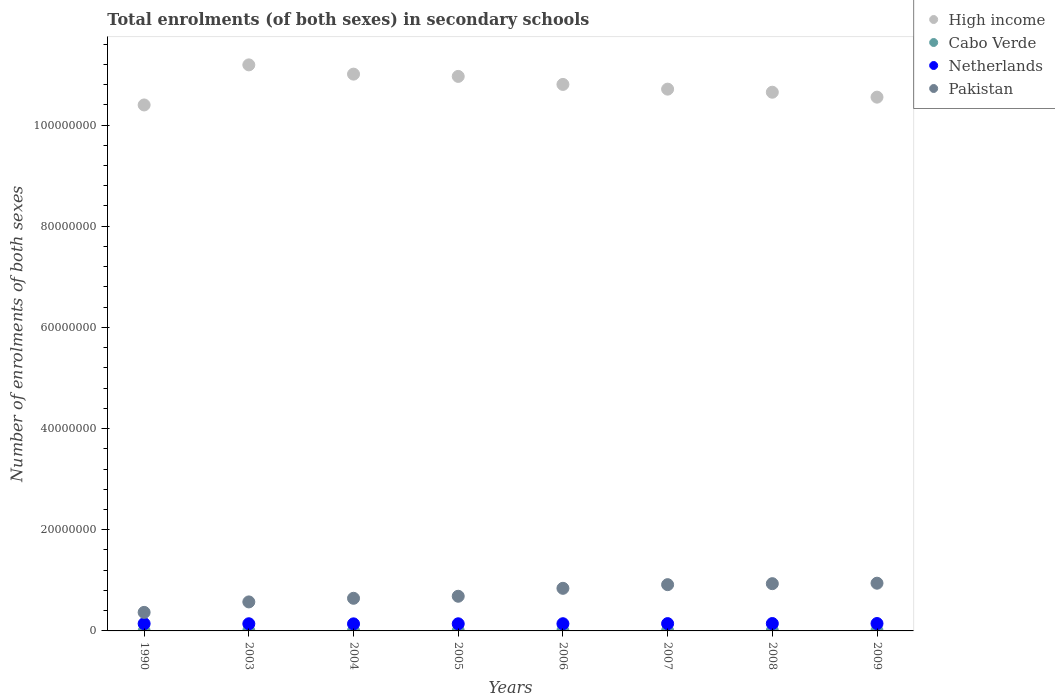What is the number of enrolments in secondary schools in Netherlands in 2003?
Offer a terse response. 1.42e+06. Across all years, what is the maximum number of enrolments in secondary schools in Pakistan?
Make the answer very short. 9.43e+06. Across all years, what is the minimum number of enrolments in secondary schools in Netherlands?
Your response must be concise. 1.40e+06. In which year was the number of enrolments in secondary schools in Pakistan maximum?
Ensure brevity in your answer.  2009. What is the total number of enrolments in secondary schools in Cabo Verde in the graph?
Offer a terse response. 4.05e+05. What is the difference between the number of enrolments in secondary schools in Cabo Verde in 1990 and that in 2005?
Give a very brief answer. -4.48e+04. What is the difference between the number of enrolments in secondary schools in Pakistan in 2006 and the number of enrolments in secondary schools in Cabo Verde in 1990?
Your response must be concise. 8.41e+06. What is the average number of enrolments in secondary schools in High income per year?
Give a very brief answer. 1.08e+08. In the year 2009, what is the difference between the number of enrolments in secondary schools in Pakistan and number of enrolments in secondary schools in High income?
Offer a terse response. -9.61e+07. In how many years, is the number of enrolments in secondary schools in Cabo Verde greater than 108000000?
Your response must be concise. 0. What is the ratio of the number of enrolments in secondary schools in High income in 2006 to that in 2007?
Provide a succinct answer. 1.01. What is the difference between the highest and the second highest number of enrolments in secondary schools in Netherlands?
Your response must be concise. 1958. What is the difference between the highest and the lowest number of enrolments in secondary schools in Pakistan?
Your response must be concise. 5.77e+06. In how many years, is the number of enrolments in secondary schools in Cabo Verde greater than the average number of enrolments in secondary schools in Cabo Verde taken over all years?
Make the answer very short. 5. Is the sum of the number of enrolments in secondary schools in High income in 1990 and 2009 greater than the maximum number of enrolments in secondary schools in Netherlands across all years?
Provide a short and direct response. Yes. Does the number of enrolments in secondary schools in Pakistan monotonically increase over the years?
Give a very brief answer. Yes. Is the number of enrolments in secondary schools in High income strictly greater than the number of enrolments in secondary schools in Pakistan over the years?
Your response must be concise. Yes. Is the number of enrolments in secondary schools in Netherlands strictly less than the number of enrolments in secondary schools in Pakistan over the years?
Give a very brief answer. Yes. How many dotlines are there?
Provide a succinct answer. 4. How many years are there in the graph?
Offer a terse response. 8. What is the difference between two consecutive major ticks on the Y-axis?
Keep it short and to the point. 2.00e+07. Are the values on the major ticks of Y-axis written in scientific E-notation?
Make the answer very short. No. Does the graph contain grids?
Your answer should be compact. No. Where does the legend appear in the graph?
Keep it short and to the point. Top right. How are the legend labels stacked?
Keep it short and to the point. Vertical. What is the title of the graph?
Provide a succinct answer. Total enrolments (of both sexes) in secondary schools. Does "Japan" appear as one of the legend labels in the graph?
Keep it short and to the point. No. What is the label or title of the X-axis?
Provide a short and direct response. Years. What is the label or title of the Y-axis?
Keep it short and to the point. Number of enrolments of both sexes. What is the Number of enrolments of both sexes of High income in 1990?
Your answer should be very brief. 1.04e+08. What is the Number of enrolments of both sexes in Cabo Verde in 1990?
Provide a short and direct response. 7866. What is the Number of enrolments of both sexes of Netherlands in 1990?
Make the answer very short. 1.44e+06. What is the Number of enrolments of both sexes in Pakistan in 1990?
Provide a short and direct response. 3.67e+06. What is the Number of enrolments of both sexes of High income in 2003?
Offer a terse response. 1.12e+08. What is the Number of enrolments of both sexes of Cabo Verde in 2003?
Give a very brief answer. 4.95e+04. What is the Number of enrolments of both sexes in Netherlands in 2003?
Your response must be concise. 1.42e+06. What is the Number of enrolments of both sexes of Pakistan in 2003?
Keep it short and to the point. 5.73e+06. What is the Number of enrolments of both sexes of High income in 2004?
Your answer should be compact. 1.10e+08. What is the Number of enrolments of both sexes of Cabo Verde in 2004?
Keep it short and to the point. 4.98e+04. What is the Number of enrolments of both sexes of Netherlands in 2004?
Your response must be concise. 1.40e+06. What is the Number of enrolments of both sexes in Pakistan in 2004?
Keep it short and to the point. 6.45e+06. What is the Number of enrolments of both sexes in High income in 2005?
Make the answer very short. 1.10e+08. What is the Number of enrolments of both sexes of Cabo Verde in 2005?
Your answer should be very brief. 5.27e+04. What is the Number of enrolments of both sexes of Netherlands in 2005?
Offer a terse response. 1.41e+06. What is the Number of enrolments of both sexes of Pakistan in 2005?
Offer a very short reply. 6.85e+06. What is the Number of enrolments of both sexes of High income in 2006?
Your response must be concise. 1.08e+08. What is the Number of enrolments of both sexes in Cabo Verde in 2006?
Your answer should be compact. 6.15e+04. What is the Number of enrolments of both sexes in Netherlands in 2006?
Your answer should be very brief. 1.42e+06. What is the Number of enrolments of both sexes in Pakistan in 2006?
Offer a terse response. 8.42e+06. What is the Number of enrolments of both sexes of High income in 2007?
Give a very brief answer. 1.07e+08. What is the Number of enrolments of both sexes of Cabo Verde in 2007?
Provide a succinct answer. 6.08e+04. What is the Number of enrolments of both sexes of Netherlands in 2007?
Keep it short and to the point. 1.44e+06. What is the Number of enrolments of both sexes of Pakistan in 2007?
Your answer should be compact. 9.15e+06. What is the Number of enrolments of both sexes of High income in 2008?
Your answer should be compact. 1.06e+08. What is the Number of enrolments of both sexes of Cabo Verde in 2008?
Ensure brevity in your answer.  6.19e+04. What is the Number of enrolments of both sexes in Netherlands in 2008?
Your response must be concise. 1.46e+06. What is the Number of enrolments of both sexes in Pakistan in 2008?
Provide a short and direct response. 9.34e+06. What is the Number of enrolments of both sexes of High income in 2009?
Keep it short and to the point. 1.06e+08. What is the Number of enrolments of both sexes in Cabo Verde in 2009?
Offer a very short reply. 6.08e+04. What is the Number of enrolments of both sexes in Netherlands in 2009?
Your response must be concise. 1.46e+06. What is the Number of enrolments of both sexes in Pakistan in 2009?
Make the answer very short. 9.43e+06. Across all years, what is the maximum Number of enrolments of both sexes in High income?
Your answer should be compact. 1.12e+08. Across all years, what is the maximum Number of enrolments of both sexes of Cabo Verde?
Ensure brevity in your answer.  6.19e+04. Across all years, what is the maximum Number of enrolments of both sexes in Netherlands?
Provide a short and direct response. 1.46e+06. Across all years, what is the maximum Number of enrolments of both sexes in Pakistan?
Keep it short and to the point. 9.43e+06. Across all years, what is the minimum Number of enrolments of both sexes in High income?
Make the answer very short. 1.04e+08. Across all years, what is the minimum Number of enrolments of both sexes of Cabo Verde?
Give a very brief answer. 7866. Across all years, what is the minimum Number of enrolments of both sexes of Netherlands?
Your answer should be very brief. 1.40e+06. Across all years, what is the minimum Number of enrolments of both sexes in Pakistan?
Provide a succinct answer. 3.67e+06. What is the total Number of enrolments of both sexes in High income in the graph?
Provide a short and direct response. 8.63e+08. What is the total Number of enrolments of both sexes of Cabo Verde in the graph?
Offer a terse response. 4.05e+05. What is the total Number of enrolments of both sexes of Netherlands in the graph?
Provide a short and direct response. 1.14e+07. What is the total Number of enrolments of both sexes of Pakistan in the graph?
Keep it short and to the point. 5.90e+07. What is the difference between the Number of enrolments of both sexes in High income in 1990 and that in 2003?
Your response must be concise. -7.92e+06. What is the difference between the Number of enrolments of both sexes of Cabo Verde in 1990 and that in 2003?
Provide a succinct answer. -4.17e+04. What is the difference between the Number of enrolments of both sexes in Netherlands in 1990 and that in 2003?
Provide a succinct answer. 2.14e+04. What is the difference between the Number of enrolments of both sexes of Pakistan in 1990 and that in 2003?
Offer a terse response. -2.07e+06. What is the difference between the Number of enrolments of both sexes of High income in 1990 and that in 2004?
Provide a short and direct response. -6.09e+06. What is the difference between the Number of enrolments of both sexes in Cabo Verde in 1990 and that in 2004?
Provide a succinct answer. -4.19e+04. What is the difference between the Number of enrolments of both sexes of Netherlands in 1990 and that in 2004?
Your answer should be compact. 3.99e+04. What is the difference between the Number of enrolments of both sexes in Pakistan in 1990 and that in 2004?
Make the answer very short. -2.78e+06. What is the difference between the Number of enrolments of both sexes in High income in 1990 and that in 2005?
Offer a terse response. -5.64e+06. What is the difference between the Number of enrolments of both sexes in Cabo Verde in 1990 and that in 2005?
Make the answer very short. -4.48e+04. What is the difference between the Number of enrolments of both sexes of Netherlands in 1990 and that in 2005?
Make the answer very short. 2.61e+04. What is the difference between the Number of enrolments of both sexes in Pakistan in 1990 and that in 2005?
Provide a succinct answer. -3.19e+06. What is the difference between the Number of enrolments of both sexes of High income in 1990 and that in 2006?
Make the answer very short. -4.06e+06. What is the difference between the Number of enrolments of both sexes of Cabo Verde in 1990 and that in 2006?
Your answer should be very brief. -5.36e+04. What is the difference between the Number of enrolments of both sexes of Netherlands in 1990 and that in 2006?
Make the answer very short. 1.33e+04. What is the difference between the Number of enrolments of both sexes in Pakistan in 1990 and that in 2006?
Offer a terse response. -4.76e+06. What is the difference between the Number of enrolments of both sexes in High income in 1990 and that in 2007?
Offer a very short reply. -3.13e+06. What is the difference between the Number of enrolments of both sexes of Cabo Verde in 1990 and that in 2007?
Give a very brief answer. -5.29e+04. What is the difference between the Number of enrolments of both sexes in Netherlands in 1990 and that in 2007?
Your answer should be compact. -7456. What is the difference between the Number of enrolments of both sexes of Pakistan in 1990 and that in 2007?
Offer a terse response. -5.48e+06. What is the difference between the Number of enrolments of both sexes of High income in 1990 and that in 2008?
Your answer should be very brief. -2.51e+06. What is the difference between the Number of enrolments of both sexes in Cabo Verde in 1990 and that in 2008?
Your response must be concise. -5.40e+04. What is the difference between the Number of enrolments of both sexes in Netherlands in 1990 and that in 2008?
Your answer should be compact. -2.39e+04. What is the difference between the Number of enrolments of both sexes of Pakistan in 1990 and that in 2008?
Give a very brief answer. -5.67e+06. What is the difference between the Number of enrolments of both sexes in High income in 1990 and that in 2009?
Provide a succinct answer. -1.54e+06. What is the difference between the Number of enrolments of both sexes in Cabo Verde in 1990 and that in 2009?
Your answer should be very brief. -5.29e+04. What is the difference between the Number of enrolments of both sexes of Netherlands in 1990 and that in 2009?
Offer a terse response. -2.59e+04. What is the difference between the Number of enrolments of both sexes in Pakistan in 1990 and that in 2009?
Provide a short and direct response. -5.77e+06. What is the difference between the Number of enrolments of both sexes of High income in 2003 and that in 2004?
Your answer should be compact. 1.83e+06. What is the difference between the Number of enrolments of both sexes in Cabo Verde in 2003 and that in 2004?
Provide a succinct answer. -268. What is the difference between the Number of enrolments of both sexes of Netherlands in 2003 and that in 2004?
Keep it short and to the point. 1.85e+04. What is the difference between the Number of enrolments of both sexes in Pakistan in 2003 and that in 2004?
Your answer should be compact. -7.15e+05. What is the difference between the Number of enrolments of both sexes in High income in 2003 and that in 2005?
Provide a succinct answer. 2.28e+06. What is the difference between the Number of enrolments of both sexes in Cabo Verde in 2003 and that in 2005?
Keep it short and to the point. -3149. What is the difference between the Number of enrolments of both sexes in Netherlands in 2003 and that in 2005?
Provide a succinct answer. 4623. What is the difference between the Number of enrolments of both sexes in Pakistan in 2003 and that in 2005?
Make the answer very short. -1.12e+06. What is the difference between the Number of enrolments of both sexes of High income in 2003 and that in 2006?
Ensure brevity in your answer.  3.86e+06. What is the difference between the Number of enrolments of both sexes of Cabo Verde in 2003 and that in 2006?
Your answer should be very brief. -1.19e+04. What is the difference between the Number of enrolments of both sexes of Netherlands in 2003 and that in 2006?
Provide a short and direct response. -8092. What is the difference between the Number of enrolments of both sexes in Pakistan in 2003 and that in 2006?
Provide a short and direct response. -2.69e+06. What is the difference between the Number of enrolments of both sexes in High income in 2003 and that in 2007?
Offer a very short reply. 4.80e+06. What is the difference between the Number of enrolments of both sexes in Cabo Verde in 2003 and that in 2007?
Give a very brief answer. -1.13e+04. What is the difference between the Number of enrolments of both sexes of Netherlands in 2003 and that in 2007?
Provide a succinct answer. -2.89e+04. What is the difference between the Number of enrolments of both sexes in Pakistan in 2003 and that in 2007?
Provide a succinct answer. -3.41e+06. What is the difference between the Number of enrolments of both sexes in High income in 2003 and that in 2008?
Your answer should be compact. 5.41e+06. What is the difference between the Number of enrolments of both sexes of Cabo Verde in 2003 and that in 2008?
Provide a short and direct response. -1.24e+04. What is the difference between the Number of enrolments of both sexes in Netherlands in 2003 and that in 2008?
Your answer should be compact. -4.53e+04. What is the difference between the Number of enrolments of both sexes of Pakistan in 2003 and that in 2008?
Ensure brevity in your answer.  -3.61e+06. What is the difference between the Number of enrolments of both sexes of High income in 2003 and that in 2009?
Provide a short and direct response. 6.38e+06. What is the difference between the Number of enrolments of both sexes of Cabo Verde in 2003 and that in 2009?
Your answer should be very brief. -1.12e+04. What is the difference between the Number of enrolments of both sexes of Netherlands in 2003 and that in 2009?
Offer a very short reply. -4.73e+04. What is the difference between the Number of enrolments of both sexes in Pakistan in 2003 and that in 2009?
Offer a terse response. -3.70e+06. What is the difference between the Number of enrolments of both sexes of High income in 2004 and that in 2005?
Ensure brevity in your answer.  4.50e+05. What is the difference between the Number of enrolments of both sexes of Cabo Verde in 2004 and that in 2005?
Ensure brevity in your answer.  -2881. What is the difference between the Number of enrolments of both sexes in Netherlands in 2004 and that in 2005?
Provide a short and direct response. -1.39e+04. What is the difference between the Number of enrolments of both sexes of Pakistan in 2004 and that in 2005?
Ensure brevity in your answer.  -4.03e+05. What is the difference between the Number of enrolments of both sexes in High income in 2004 and that in 2006?
Keep it short and to the point. 2.03e+06. What is the difference between the Number of enrolments of both sexes in Cabo Verde in 2004 and that in 2006?
Give a very brief answer. -1.17e+04. What is the difference between the Number of enrolments of both sexes of Netherlands in 2004 and that in 2006?
Your answer should be very brief. -2.66e+04. What is the difference between the Number of enrolments of both sexes in Pakistan in 2004 and that in 2006?
Make the answer very short. -1.97e+06. What is the difference between the Number of enrolments of both sexes in High income in 2004 and that in 2007?
Your answer should be compact. 2.97e+06. What is the difference between the Number of enrolments of both sexes of Cabo Verde in 2004 and that in 2007?
Your answer should be very brief. -1.10e+04. What is the difference between the Number of enrolments of both sexes of Netherlands in 2004 and that in 2007?
Make the answer very short. -4.74e+04. What is the difference between the Number of enrolments of both sexes in Pakistan in 2004 and that in 2007?
Your response must be concise. -2.70e+06. What is the difference between the Number of enrolments of both sexes of High income in 2004 and that in 2008?
Give a very brief answer. 3.58e+06. What is the difference between the Number of enrolments of both sexes of Cabo Verde in 2004 and that in 2008?
Provide a short and direct response. -1.21e+04. What is the difference between the Number of enrolments of both sexes of Netherlands in 2004 and that in 2008?
Your response must be concise. -6.38e+04. What is the difference between the Number of enrolments of both sexes of Pakistan in 2004 and that in 2008?
Offer a very short reply. -2.89e+06. What is the difference between the Number of enrolments of both sexes of High income in 2004 and that in 2009?
Provide a succinct answer. 4.55e+06. What is the difference between the Number of enrolments of both sexes of Cabo Verde in 2004 and that in 2009?
Your response must be concise. -1.10e+04. What is the difference between the Number of enrolments of both sexes of Netherlands in 2004 and that in 2009?
Offer a very short reply. -6.58e+04. What is the difference between the Number of enrolments of both sexes of Pakistan in 2004 and that in 2009?
Give a very brief answer. -2.98e+06. What is the difference between the Number of enrolments of both sexes in High income in 2005 and that in 2006?
Offer a very short reply. 1.58e+06. What is the difference between the Number of enrolments of both sexes of Cabo Verde in 2005 and that in 2006?
Keep it short and to the point. -8794. What is the difference between the Number of enrolments of both sexes in Netherlands in 2005 and that in 2006?
Provide a succinct answer. -1.27e+04. What is the difference between the Number of enrolments of both sexes of Pakistan in 2005 and that in 2006?
Offer a very short reply. -1.57e+06. What is the difference between the Number of enrolments of both sexes in High income in 2005 and that in 2007?
Give a very brief answer. 2.52e+06. What is the difference between the Number of enrolments of both sexes of Cabo Verde in 2005 and that in 2007?
Make the answer very short. -8112. What is the difference between the Number of enrolments of both sexes in Netherlands in 2005 and that in 2007?
Ensure brevity in your answer.  -3.35e+04. What is the difference between the Number of enrolments of both sexes of Pakistan in 2005 and that in 2007?
Your answer should be compact. -2.29e+06. What is the difference between the Number of enrolments of both sexes of High income in 2005 and that in 2008?
Your answer should be very brief. 3.13e+06. What is the difference between the Number of enrolments of both sexes of Cabo Verde in 2005 and that in 2008?
Your response must be concise. -9235. What is the difference between the Number of enrolments of both sexes in Netherlands in 2005 and that in 2008?
Make the answer very short. -5.00e+04. What is the difference between the Number of enrolments of both sexes in Pakistan in 2005 and that in 2008?
Your answer should be very brief. -2.49e+06. What is the difference between the Number of enrolments of both sexes of High income in 2005 and that in 2009?
Offer a terse response. 4.10e+06. What is the difference between the Number of enrolments of both sexes of Cabo Verde in 2005 and that in 2009?
Give a very brief answer. -8098. What is the difference between the Number of enrolments of both sexes of Netherlands in 2005 and that in 2009?
Ensure brevity in your answer.  -5.19e+04. What is the difference between the Number of enrolments of both sexes of Pakistan in 2005 and that in 2009?
Offer a terse response. -2.58e+06. What is the difference between the Number of enrolments of both sexes of High income in 2006 and that in 2007?
Keep it short and to the point. 9.32e+05. What is the difference between the Number of enrolments of both sexes in Cabo Verde in 2006 and that in 2007?
Your answer should be compact. 682. What is the difference between the Number of enrolments of both sexes in Netherlands in 2006 and that in 2007?
Offer a very short reply. -2.08e+04. What is the difference between the Number of enrolments of both sexes in Pakistan in 2006 and that in 2007?
Make the answer very short. -7.24e+05. What is the difference between the Number of enrolments of both sexes in High income in 2006 and that in 2008?
Ensure brevity in your answer.  1.54e+06. What is the difference between the Number of enrolments of both sexes of Cabo Verde in 2006 and that in 2008?
Your response must be concise. -441. What is the difference between the Number of enrolments of both sexes in Netherlands in 2006 and that in 2008?
Your response must be concise. -3.72e+04. What is the difference between the Number of enrolments of both sexes of Pakistan in 2006 and that in 2008?
Make the answer very short. -9.19e+05. What is the difference between the Number of enrolments of both sexes in High income in 2006 and that in 2009?
Offer a very short reply. 2.52e+06. What is the difference between the Number of enrolments of both sexes in Cabo Verde in 2006 and that in 2009?
Keep it short and to the point. 696. What is the difference between the Number of enrolments of both sexes in Netherlands in 2006 and that in 2009?
Give a very brief answer. -3.92e+04. What is the difference between the Number of enrolments of both sexes of Pakistan in 2006 and that in 2009?
Offer a terse response. -1.01e+06. What is the difference between the Number of enrolments of both sexes of High income in 2007 and that in 2008?
Give a very brief answer. 6.11e+05. What is the difference between the Number of enrolments of both sexes in Cabo Verde in 2007 and that in 2008?
Ensure brevity in your answer.  -1123. What is the difference between the Number of enrolments of both sexes in Netherlands in 2007 and that in 2008?
Provide a short and direct response. -1.64e+04. What is the difference between the Number of enrolments of both sexes in Pakistan in 2007 and that in 2008?
Your answer should be compact. -1.95e+05. What is the difference between the Number of enrolments of both sexes in High income in 2007 and that in 2009?
Provide a short and direct response. 1.58e+06. What is the difference between the Number of enrolments of both sexes in Cabo Verde in 2007 and that in 2009?
Your response must be concise. 14. What is the difference between the Number of enrolments of both sexes in Netherlands in 2007 and that in 2009?
Ensure brevity in your answer.  -1.84e+04. What is the difference between the Number of enrolments of both sexes of Pakistan in 2007 and that in 2009?
Make the answer very short. -2.88e+05. What is the difference between the Number of enrolments of both sexes in High income in 2008 and that in 2009?
Your answer should be compact. 9.72e+05. What is the difference between the Number of enrolments of both sexes in Cabo Verde in 2008 and that in 2009?
Provide a short and direct response. 1137. What is the difference between the Number of enrolments of both sexes of Netherlands in 2008 and that in 2009?
Offer a terse response. -1958. What is the difference between the Number of enrolments of both sexes of Pakistan in 2008 and that in 2009?
Your answer should be very brief. -9.30e+04. What is the difference between the Number of enrolments of both sexes of High income in 1990 and the Number of enrolments of both sexes of Cabo Verde in 2003?
Make the answer very short. 1.04e+08. What is the difference between the Number of enrolments of both sexes in High income in 1990 and the Number of enrolments of both sexes in Netherlands in 2003?
Keep it short and to the point. 1.03e+08. What is the difference between the Number of enrolments of both sexes of High income in 1990 and the Number of enrolments of both sexes of Pakistan in 2003?
Give a very brief answer. 9.82e+07. What is the difference between the Number of enrolments of both sexes in Cabo Verde in 1990 and the Number of enrolments of both sexes in Netherlands in 2003?
Offer a very short reply. -1.41e+06. What is the difference between the Number of enrolments of both sexes of Cabo Verde in 1990 and the Number of enrolments of both sexes of Pakistan in 2003?
Give a very brief answer. -5.73e+06. What is the difference between the Number of enrolments of both sexes of Netherlands in 1990 and the Number of enrolments of both sexes of Pakistan in 2003?
Offer a very short reply. -4.30e+06. What is the difference between the Number of enrolments of both sexes in High income in 1990 and the Number of enrolments of both sexes in Cabo Verde in 2004?
Give a very brief answer. 1.04e+08. What is the difference between the Number of enrolments of both sexes in High income in 1990 and the Number of enrolments of both sexes in Netherlands in 2004?
Give a very brief answer. 1.03e+08. What is the difference between the Number of enrolments of both sexes in High income in 1990 and the Number of enrolments of both sexes in Pakistan in 2004?
Your answer should be compact. 9.75e+07. What is the difference between the Number of enrolments of both sexes in Cabo Verde in 1990 and the Number of enrolments of both sexes in Netherlands in 2004?
Keep it short and to the point. -1.39e+06. What is the difference between the Number of enrolments of both sexes in Cabo Verde in 1990 and the Number of enrolments of both sexes in Pakistan in 2004?
Give a very brief answer. -6.44e+06. What is the difference between the Number of enrolments of both sexes of Netherlands in 1990 and the Number of enrolments of both sexes of Pakistan in 2004?
Your response must be concise. -5.01e+06. What is the difference between the Number of enrolments of both sexes in High income in 1990 and the Number of enrolments of both sexes in Cabo Verde in 2005?
Provide a succinct answer. 1.04e+08. What is the difference between the Number of enrolments of both sexes in High income in 1990 and the Number of enrolments of both sexes in Netherlands in 2005?
Offer a terse response. 1.03e+08. What is the difference between the Number of enrolments of both sexes of High income in 1990 and the Number of enrolments of both sexes of Pakistan in 2005?
Make the answer very short. 9.71e+07. What is the difference between the Number of enrolments of both sexes in Cabo Verde in 1990 and the Number of enrolments of both sexes in Netherlands in 2005?
Your response must be concise. -1.40e+06. What is the difference between the Number of enrolments of both sexes in Cabo Verde in 1990 and the Number of enrolments of both sexes in Pakistan in 2005?
Ensure brevity in your answer.  -6.84e+06. What is the difference between the Number of enrolments of both sexes of Netherlands in 1990 and the Number of enrolments of both sexes of Pakistan in 2005?
Give a very brief answer. -5.42e+06. What is the difference between the Number of enrolments of both sexes in High income in 1990 and the Number of enrolments of both sexes in Cabo Verde in 2006?
Offer a very short reply. 1.04e+08. What is the difference between the Number of enrolments of both sexes of High income in 1990 and the Number of enrolments of both sexes of Netherlands in 2006?
Provide a short and direct response. 1.03e+08. What is the difference between the Number of enrolments of both sexes in High income in 1990 and the Number of enrolments of both sexes in Pakistan in 2006?
Keep it short and to the point. 9.55e+07. What is the difference between the Number of enrolments of both sexes in Cabo Verde in 1990 and the Number of enrolments of both sexes in Netherlands in 2006?
Offer a very short reply. -1.42e+06. What is the difference between the Number of enrolments of both sexes in Cabo Verde in 1990 and the Number of enrolments of both sexes in Pakistan in 2006?
Offer a very short reply. -8.41e+06. What is the difference between the Number of enrolments of both sexes of Netherlands in 1990 and the Number of enrolments of both sexes of Pakistan in 2006?
Provide a short and direct response. -6.98e+06. What is the difference between the Number of enrolments of both sexes in High income in 1990 and the Number of enrolments of both sexes in Cabo Verde in 2007?
Your answer should be compact. 1.04e+08. What is the difference between the Number of enrolments of both sexes of High income in 1990 and the Number of enrolments of both sexes of Netherlands in 2007?
Your answer should be very brief. 1.03e+08. What is the difference between the Number of enrolments of both sexes of High income in 1990 and the Number of enrolments of both sexes of Pakistan in 2007?
Keep it short and to the point. 9.48e+07. What is the difference between the Number of enrolments of both sexes in Cabo Verde in 1990 and the Number of enrolments of both sexes in Netherlands in 2007?
Provide a short and direct response. -1.44e+06. What is the difference between the Number of enrolments of both sexes of Cabo Verde in 1990 and the Number of enrolments of both sexes of Pakistan in 2007?
Provide a succinct answer. -9.14e+06. What is the difference between the Number of enrolments of both sexes of Netherlands in 1990 and the Number of enrolments of both sexes of Pakistan in 2007?
Make the answer very short. -7.71e+06. What is the difference between the Number of enrolments of both sexes of High income in 1990 and the Number of enrolments of both sexes of Cabo Verde in 2008?
Your answer should be very brief. 1.04e+08. What is the difference between the Number of enrolments of both sexes of High income in 1990 and the Number of enrolments of both sexes of Netherlands in 2008?
Ensure brevity in your answer.  1.03e+08. What is the difference between the Number of enrolments of both sexes in High income in 1990 and the Number of enrolments of both sexes in Pakistan in 2008?
Your answer should be very brief. 9.46e+07. What is the difference between the Number of enrolments of both sexes of Cabo Verde in 1990 and the Number of enrolments of both sexes of Netherlands in 2008?
Provide a short and direct response. -1.45e+06. What is the difference between the Number of enrolments of both sexes of Cabo Verde in 1990 and the Number of enrolments of both sexes of Pakistan in 2008?
Keep it short and to the point. -9.33e+06. What is the difference between the Number of enrolments of both sexes in Netherlands in 1990 and the Number of enrolments of both sexes in Pakistan in 2008?
Make the answer very short. -7.90e+06. What is the difference between the Number of enrolments of both sexes of High income in 1990 and the Number of enrolments of both sexes of Cabo Verde in 2009?
Ensure brevity in your answer.  1.04e+08. What is the difference between the Number of enrolments of both sexes in High income in 1990 and the Number of enrolments of both sexes in Netherlands in 2009?
Offer a terse response. 1.03e+08. What is the difference between the Number of enrolments of both sexes of High income in 1990 and the Number of enrolments of both sexes of Pakistan in 2009?
Offer a terse response. 9.45e+07. What is the difference between the Number of enrolments of both sexes in Cabo Verde in 1990 and the Number of enrolments of both sexes in Netherlands in 2009?
Provide a short and direct response. -1.45e+06. What is the difference between the Number of enrolments of both sexes in Cabo Verde in 1990 and the Number of enrolments of both sexes in Pakistan in 2009?
Your response must be concise. -9.43e+06. What is the difference between the Number of enrolments of both sexes in Netherlands in 1990 and the Number of enrolments of both sexes in Pakistan in 2009?
Provide a succinct answer. -8.00e+06. What is the difference between the Number of enrolments of both sexes of High income in 2003 and the Number of enrolments of both sexes of Cabo Verde in 2004?
Your answer should be very brief. 1.12e+08. What is the difference between the Number of enrolments of both sexes of High income in 2003 and the Number of enrolments of both sexes of Netherlands in 2004?
Give a very brief answer. 1.10e+08. What is the difference between the Number of enrolments of both sexes of High income in 2003 and the Number of enrolments of both sexes of Pakistan in 2004?
Offer a very short reply. 1.05e+08. What is the difference between the Number of enrolments of both sexes in Cabo Verde in 2003 and the Number of enrolments of both sexes in Netherlands in 2004?
Offer a very short reply. -1.35e+06. What is the difference between the Number of enrolments of both sexes of Cabo Verde in 2003 and the Number of enrolments of both sexes of Pakistan in 2004?
Provide a short and direct response. -6.40e+06. What is the difference between the Number of enrolments of both sexes in Netherlands in 2003 and the Number of enrolments of both sexes in Pakistan in 2004?
Your answer should be very brief. -5.03e+06. What is the difference between the Number of enrolments of both sexes of High income in 2003 and the Number of enrolments of both sexes of Cabo Verde in 2005?
Ensure brevity in your answer.  1.12e+08. What is the difference between the Number of enrolments of both sexes of High income in 2003 and the Number of enrolments of both sexes of Netherlands in 2005?
Your response must be concise. 1.10e+08. What is the difference between the Number of enrolments of both sexes of High income in 2003 and the Number of enrolments of both sexes of Pakistan in 2005?
Make the answer very short. 1.05e+08. What is the difference between the Number of enrolments of both sexes of Cabo Verde in 2003 and the Number of enrolments of both sexes of Netherlands in 2005?
Offer a terse response. -1.36e+06. What is the difference between the Number of enrolments of both sexes of Cabo Verde in 2003 and the Number of enrolments of both sexes of Pakistan in 2005?
Offer a terse response. -6.80e+06. What is the difference between the Number of enrolments of both sexes of Netherlands in 2003 and the Number of enrolments of both sexes of Pakistan in 2005?
Offer a terse response. -5.44e+06. What is the difference between the Number of enrolments of both sexes of High income in 2003 and the Number of enrolments of both sexes of Cabo Verde in 2006?
Provide a short and direct response. 1.12e+08. What is the difference between the Number of enrolments of both sexes of High income in 2003 and the Number of enrolments of both sexes of Netherlands in 2006?
Make the answer very short. 1.10e+08. What is the difference between the Number of enrolments of both sexes in High income in 2003 and the Number of enrolments of both sexes in Pakistan in 2006?
Your answer should be very brief. 1.03e+08. What is the difference between the Number of enrolments of both sexes of Cabo Verde in 2003 and the Number of enrolments of both sexes of Netherlands in 2006?
Your answer should be compact. -1.37e+06. What is the difference between the Number of enrolments of both sexes of Cabo Verde in 2003 and the Number of enrolments of both sexes of Pakistan in 2006?
Your answer should be very brief. -8.37e+06. What is the difference between the Number of enrolments of both sexes in Netherlands in 2003 and the Number of enrolments of both sexes in Pakistan in 2006?
Give a very brief answer. -7.01e+06. What is the difference between the Number of enrolments of both sexes in High income in 2003 and the Number of enrolments of both sexes in Cabo Verde in 2007?
Ensure brevity in your answer.  1.12e+08. What is the difference between the Number of enrolments of both sexes of High income in 2003 and the Number of enrolments of both sexes of Netherlands in 2007?
Offer a terse response. 1.10e+08. What is the difference between the Number of enrolments of both sexes of High income in 2003 and the Number of enrolments of both sexes of Pakistan in 2007?
Your answer should be very brief. 1.03e+08. What is the difference between the Number of enrolments of both sexes of Cabo Verde in 2003 and the Number of enrolments of both sexes of Netherlands in 2007?
Offer a terse response. -1.39e+06. What is the difference between the Number of enrolments of both sexes of Cabo Verde in 2003 and the Number of enrolments of both sexes of Pakistan in 2007?
Your answer should be compact. -9.10e+06. What is the difference between the Number of enrolments of both sexes of Netherlands in 2003 and the Number of enrolments of both sexes of Pakistan in 2007?
Ensure brevity in your answer.  -7.73e+06. What is the difference between the Number of enrolments of both sexes in High income in 2003 and the Number of enrolments of both sexes in Cabo Verde in 2008?
Your answer should be very brief. 1.12e+08. What is the difference between the Number of enrolments of both sexes in High income in 2003 and the Number of enrolments of both sexes in Netherlands in 2008?
Keep it short and to the point. 1.10e+08. What is the difference between the Number of enrolments of both sexes in High income in 2003 and the Number of enrolments of both sexes in Pakistan in 2008?
Your answer should be compact. 1.03e+08. What is the difference between the Number of enrolments of both sexes in Cabo Verde in 2003 and the Number of enrolments of both sexes in Netherlands in 2008?
Provide a succinct answer. -1.41e+06. What is the difference between the Number of enrolments of both sexes of Cabo Verde in 2003 and the Number of enrolments of both sexes of Pakistan in 2008?
Offer a terse response. -9.29e+06. What is the difference between the Number of enrolments of both sexes of Netherlands in 2003 and the Number of enrolments of both sexes of Pakistan in 2008?
Keep it short and to the point. -7.92e+06. What is the difference between the Number of enrolments of both sexes of High income in 2003 and the Number of enrolments of both sexes of Cabo Verde in 2009?
Your response must be concise. 1.12e+08. What is the difference between the Number of enrolments of both sexes of High income in 2003 and the Number of enrolments of both sexes of Netherlands in 2009?
Give a very brief answer. 1.10e+08. What is the difference between the Number of enrolments of both sexes of High income in 2003 and the Number of enrolments of both sexes of Pakistan in 2009?
Provide a short and direct response. 1.02e+08. What is the difference between the Number of enrolments of both sexes of Cabo Verde in 2003 and the Number of enrolments of both sexes of Netherlands in 2009?
Ensure brevity in your answer.  -1.41e+06. What is the difference between the Number of enrolments of both sexes of Cabo Verde in 2003 and the Number of enrolments of both sexes of Pakistan in 2009?
Ensure brevity in your answer.  -9.38e+06. What is the difference between the Number of enrolments of both sexes of Netherlands in 2003 and the Number of enrolments of both sexes of Pakistan in 2009?
Make the answer very short. -8.02e+06. What is the difference between the Number of enrolments of both sexes in High income in 2004 and the Number of enrolments of both sexes in Cabo Verde in 2005?
Offer a terse response. 1.10e+08. What is the difference between the Number of enrolments of both sexes in High income in 2004 and the Number of enrolments of both sexes in Netherlands in 2005?
Keep it short and to the point. 1.09e+08. What is the difference between the Number of enrolments of both sexes of High income in 2004 and the Number of enrolments of both sexes of Pakistan in 2005?
Your answer should be very brief. 1.03e+08. What is the difference between the Number of enrolments of both sexes in Cabo Verde in 2004 and the Number of enrolments of both sexes in Netherlands in 2005?
Your response must be concise. -1.36e+06. What is the difference between the Number of enrolments of both sexes in Cabo Verde in 2004 and the Number of enrolments of both sexes in Pakistan in 2005?
Your answer should be compact. -6.80e+06. What is the difference between the Number of enrolments of both sexes of Netherlands in 2004 and the Number of enrolments of both sexes of Pakistan in 2005?
Your answer should be very brief. -5.46e+06. What is the difference between the Number of enrolments of both sexes in High income in 2004 and the Number of enrolments of both sexes in Cabo Verde in 2006?
Provide a succinct answer. 1.10e+08. What is the difference between the Number of enrolments of both sexes in High income in 2004 and the Number of enrolments of both sexes in Netherlands in 2006?
Ensure brevity in your answer.  1.09e+08. What is the difference between the Number of enrolments of both sexes in High income in 2004 and the Number of enrolments of both sexes in Pakistan in 2006?
Keep it short and to the point. 1.02e+08. What is the difference between the Number of enrolments of both sexes in Cabo Verde in 2004 and the Number of enrolments of both sexes in Netherlands in 2006?
Your answer should be compact. -1.37e+06. What is the difference between the Number of enrolments of both sexes of Cabo Verde in 2004 and the Number of enrolments of both sexes of Pakistan in 2006?
Offer a very short reply. -8.37e+06. What is the difference between the Number of enrolments of both sexes of Netherlands in 2004 and the Number of enrolments of both sexes of Pakistan in 2006?
Keep it short and to the point. -7.02e+06. What is the difference between the Number of enrolments of both sexes of High income in 2004 and the Number of enrolments of both sexes of Cabo Verde in 2007?
Your response must be concise. 1.10e+08. What is the difference between the Number of enrolments of both sexes of High income in 2004 and the Number of enrolments of both sexes of Netherlands in 2007?
Make the answer very short. 1.09e+08. What is the difference between the Number of enrolments of both sexes in High income in 2004 and the Number of enrolments of both sexes in Pakistan in 2007?
Ensure brevity in your answer.  1.01e+08. What is the difference between the Number of enrolments of both sexes of Cabo Verde in 2004 and the Number of enrolments of both sexes of Netherlands in 2007?
Offer a very short reply. -1.39e+06. What is the difference between the Number of enrolments of both sexes of Cabo Verde in 2004 and the Number of enrolments of both sexes of Pakistan in 2007?
Your answer should be compact. -9.10e+06. What is the difference between the Number of enrolments of both sexes of Netherlands in 2004 and the Number of enrolments of both sexes of Pakistan in 2007?
Ensure brevity in your answer.  -7.75e+06. What is the difference between the Number of enrolments of both sexes in High income in 2004 and the Number of enrolments of both sexes in Cabo Verde in 2008?
Offer a terse response. 1.10e+08. What is the difference between the Number of enrolments of both sexes of High income in 2004 and the Number of enrolments of both sexes of Netherlands in 2008?
Ensure brevity in your answer.  1.09e+08. What is the difference between the Number of enrolments of both sexes of High income in 2004 and the Number of enrolments of both sexes of Pakistan in 2008?
Give a very brief answer. 1.01e+08. What is the difference between the Number of enrolments of both sexes in Cabo Verde in 2004 and the Number of enrolments of both sexes in Netherlands in 2008?
Offer a terse response. -1.41e+06. What is the difference between the Number of enrolments of both sexes of Cabo Verde in 2004 and the Number of enrolments of both sexes of Pakistan in 2008?
Provide a succinct answer. -9.29e+06. What is the difference between the Number of enrolments of both sexes in Netherlands in 2004 and the Number of enrolments of both sexes in Pakistan in 2008?
Your response must be concise. -7.94e+06. What is the difference between the Number of enrolments of both sexes of High income in 2004 and the Number of enrolments of both sexes of Cabo Verde in 2009?
Offer a terse response. 1.10e+08. What is the difference between the Number of enrolments of both sexes of High income in 2004 and the Number of enrolments of both sexes of Netherlands in 2009?
Make the answer very short. 1.09e+08. What is the difference between the Number of enrolments of both sexes in High income in 2004 and the Number of enrolments of both sexes in Pakistan in 2009?
Ensure brevity in your answer.  1.01e+08. What is the difference between the Number of enrolments of both sexes in Cabo Verde in 2004 and the Number of enrolments of both sexes in Netherlands in 2009?
Your answer should be very brief. -1.41e+06. What is the difference between the Number of enrolments of both sexes of Cabo Verde in 2004 and the Number of enrolments of both sexes of Pakistan in 2009?
Provide a short and direct response. -9.38e+06. What is the difference between the Number of enrolments of both sexes of Netherlands in 2004 and the Number of enrolments of both sexes of Pakistan in 2009?
Offer a very short reply. -8.04e+06. What is the difference between the Number of enrolments of both sexes in High income in 2005 and the Number of enrolments of both sexes in Cabo Verde in 2006?
Your answer should be very brief. 1.10e+08. What is the difference between the Number of enrolments of both sexes of High income in 2005 and the Number of enrolments of both sexes of Netherlands in 2006?
Keep it short and to the point. 1.08e+08. What is the difference between the Number of enrolments of both sexes in High income in 2005 and the Number of enrolments of both sexes in Pakistan in 2006?
Give a very brief answer. 1.01e+08. What is the difference between the Number of enrolments of both sexes of Cabo Verde in 2005 and the Number of enrolments of both sexes of Netherlands in 2006?
Offer a terse response. -1.37e+06. What is the difference between the Number of enrolments of both sexes of Cabo Verde in 2005 and the Number of enrolments of both sexes of Pakistan in 2006?
Provide a succinct answer. -8.37e+06. What is the difference between the Number of enrolments of both sexes of Netherlands in 2005 and the Number of enrolments of both sexes of Pakistan in 2006?
Offer a very short reply. -7.01e+06. What is the difference between the Number of enrolments of both sexes in High income in 2005 and the Number of enrolments of both sexes in Cabo Verde in 2007?
Your response must be concise. 1.10e+08. What is the difference between the Number of enrolments of both sexes in High income in 2005 and the Number of enrolments of both sexes in Netherlands in 2007?
Keep it short and to the point. 1.08e+08. What is the difference between the Number of enrolments of both sexes of High income in 2005 and the Number of enrolments of both sexes of Pakistan in 2007?
Ensure brevity in your answer.  1.00e+08. What is the difference between the Number of enrolments of both sexes in Cabo Verde in 2005 and the Number of enrolments of both sexes in Netherlands in 2007?
Provide a succinct answer. -1.39e+06. What is the difference between the Number of enrolments of both sexes of Cabo Verde in 2005 and the Number of enrolments of both sexes of Pakistan in 2007?
Keep it short and to the point. -9.09e+06. What is the difference between the Number of enrolments of both sexes of Netherlands in 2005 and the Number of enrolments of both sexes of Pakistan in 2007?
Keep it short and to the point. -7.73e+06. What is the difference between the Number of enrolments of both sexes of High income in 2005 and the Number of enrolments of both sexes of Cabo Verde in 2008?
Provide a succinct answer. 1.10e+08. What is the difference between the Number of enrolments of both sexes of High income in 2005 and the Number of enrolments of both sexes of Netherlands in 2008?
Provide a short and direct response. 1.08e+08. What is the difference between the Number of enrolments of both sexes in High income in 2005 and the Number of enrolments of both sexes in Pakistan in 2008?
Provide a succinct answer. 1.00e+08. What is the difference between the Number of enrolments of both sexes in Cabo Verde in 2005 and the Number of enrolments of both sexes in Netherlands in 2008?
Give a very brief answer. -1.41e+06. What is the difference between the Number of enrolments of both sexes in Cabo Verde in 2005 and the Number of enrolments of both sexes in Pakistan in 2008?
Offer a terse response. -9.29e+06. What is the difference between the Number of enrolments of both sexes of Netherlands in 2005 and the Number of enrolments of both sexes of Pakistan in 2008?
Offer a very short reply. -7.93e+06. What is the difference between the Number of enrolments of both sexes of High income in 2005 and the Number of enrolments of both sexes of Cabo Verde in 2009?
Provide a short and direct response. 1.10e+08. What is the difference between the Number of enrolments of both sexes of High income in 2005 and the Number of enrolments of both sexes of Netherlands in 2009?
Keep it short and to the point. 1.08e+08. What is the difference between the Number of enrolments of both sexes in High income in 2005 and the Number of enrolments of both sexes in Pakistan in 2009?
Make the answer very short. 1.00e+08. What is the difference between the Number of enrolments of both sexes in Cabo Verde in 2005 and the Number of enrolments of both sexes in Netherlands in 2009?
Your answer should be very brief. -1.41e+06. What is the difference between the Number of enrolments of both sexes in Cabo Verde in 2005 and the Number of enrolments of both sexes in Pakistan in 2009?
Your answer should be very brief. -9.38e+06. What is the difference between the Number of enrolments of both sexes in Netherlands in 2005 and the Number of enrolments of both sexes in Pakistan in 2009?
Make the answer very short. -8.02e+06. What is the difference between the Number of enrolments of both sexes of High income in 2006 and the Number of enrolments of both sexes of Cabo Verde in 2007?
Provide a succinct answer. 1.08e+08. What is the difference between the Number of enrolments of both sexes of High income in 2006 and the Number of enrolments of both sexes of Netherlands in 2007?
Your response must be concise. 1.07e+08. What is the difference between the Number of enrolments of both sexes of High income in 2006 and the Number of enrolments of both sexes of Pakistan in 2007?
Provide a succinct answer. 9.89e+07. What is the difference between the Number of enrolments of both sexes of Cabo Verde in 2006 and the Number of enrolments of both sexes of Netherlands in 2007?
Give a very brief answer. -1.38e+06. What is the difference between the Number of enrolments of both sexes of Cabo Verde in 2006 and the Number of enrolments of both sexes of Pakistan in 2007?
Your answer should be compact. -9.08e+06. What is the difference between the Number of enrolments of both sexes in Netherlands in 2006 and the Number of enrolments of both sexes in Pakistan in 2007?
Provide a succinct answer. -7.72e+06. What is the difference between the Number of enrolments of both sexes of High income in 2006 and the Number of enrolments of both sexes of Cabo Verde in 2008?
Provide a short and direct response. 1.08e+08. What is the difference between the Number of enrolments of both sexes in High income in 2006 and the Number of enrolments of both sexes in Netherlands in 2008?
Provide a short and direct response. 1.07e+08. What is the difference between the Number of enrolments of both sexes of High income in 2006 and the Number of enrolments of both sexes of Pakistan in 2008?
Give a very brief answer. 9.87e+07. What is the difference between the Number of enrolments of both sexes of Cabo Verde in 2006 and the Number of enrolments of both sexes of Netherlands in 2008?
Provide a succinct answer. -1.40e+06. What is the difference between the Number of enrolments of both sexes in Cabo Verde in 2006 and the Number of enrolments of both sexes in Pakistan in 2008?
Give a very brief answer. -9.28e+06. What is the difference between the Number of enrolments of both sexes of Netherlands in 2006 and the Number of enrolments of both sexes of Pakistan in 2008?
Your answer should be very brief. -7.92e+06. What is the difference between the Number of enrolments of both sexes in High income in 2006 and the Number of enrolments of both sexes in Cabo Verde in 2009?
Your response must be concise. 1.08e+08. What is the difference between the Number of enrolments of both sexes of High income in 2006 and the Number of enrolments of both sexes of Netherlands in 2009?
Give a very brief answer. 1.07e+08. What is the difference between the Number of enrolments of both sexes in High income in 2006 and the Number of enrolments of both sexes in Pakistan in 2009?
Give a very brief answer. 9.86e+07. What is the difference between the Number of enrolments of both sexes of Cabo Verde in 2006 and the Number of enrolments of both sexes of Netherlands in 2009?
Your answer should be very brief. -1.40e+06. What is the difference between the Number of enrolments of both sexes of Cabo Verde in 2006 and the Number of enrolments of both sexes of Pakistan in 2009?
Your answer should be compact. -9.37e+06. What is the difference between the Number of enrolments of both sexes of Netherlands in 2006 and the Number of enrolments of both sexes of Pakistan in 2009?
Your response must be concise. -8.01e+06. What is the difference between the Number of enrolments of both sexes of High income in 2007 and the Number of enrolments of both sexes of Cabo Verde in 2008?
Offer a very short reply. 1.07e+08. What is the difference between the Number of enrolments of both sexes in High income in 2007 and the Number of enrolments of both sexes in Netherlands in 2008?
Keep it short and to the point. 1.06e+08. What is the difference between the Number of enrolments of both sexes in High income in 2007 and the Number of enrolments of both sexes in Pakistan in 2008?
Keep it short and to the point. 9.78e+07. What is the difference between the Number of enrolments of both sexes of Cabo Verde in 2007 and the Number of enrolments of both sexes of Netherlands in 2008?
Keep it short and to the point. -1.40e+06. What is the difference between the Number of enrolments of both sexes in Cabo Verde in 2007 and the Number of enrolments of both sexes in Pakistan in 2008?
Keep it short and to the point. -9.28e+06. What is the difference between the Number of enrolments of both sexes of Netherlands in 2007 and the Number of enrolments of both sexes of Pakistan in 2008?
Keep it short and to the point. -7.90e+06. What is the difference between the Number of enrolments of both sexes in High income in 2007 and the Number of enrolments of both sexes in Cabo Verde in 2009?
Your answer should be very brief. 1.07e+08. What is the difference between the Number of enrolments of both sexes of High income in 2007 and the Number of enrolments of both sexes of Netherlands in 2009?
Keep it short and to the point. 1.06e+08. What is the difference between the Number of enrolments of both sexes in High income in 2007 and the Number of enrolments of both sexes in Pakistan in 2009?
Keep it short and to the point. 9.77e+07. What is the difference between the Number of enrolments of both sexes of Cabo Verde in 2007 and the Number of enrolments of both sexes of Netherlands in 2009?
Give a very brief answer. -1.40e+06. What is the difference between the Number of enrolments of both sexes of Cabo Verde in 2007 and the Number of enrolments of both sexes of Pakistan in 2009?
Provide a short and direct response. -9.37e+06. What is the difference between the Number of enrolments of both sexes of Netherlands in 2007 and the Number of enrolments of both sexes of Pakistan in 2009?
Your answer should be very brief. -7.99e+06. What is the difference between the Number of enrolments of both sexes of High income in 2008 and the Number of enrolments of both sexes of Cabo Verde in 2009?
Your response must be concise. 1.06e+08. What is the difference between the Number of enrolments of both sexes in High income in 2008 and the Number of enrolments of both sexes in Netherlands in 2009?
Provide a short and direct response. 1.05e+08. What is the difference between the Number of enrolments of both sexes of High income in 2008 and the Number of enrolments of both sexes of Pakistan in 2009?
Provide a short and direct response. 9.70e+07. What is the difference between the Number of enrolments of both sexes of Cabo Verde in 2008 and the Number of enrolments of both sexes of Netherlands in 2009?
Your answer should be very brief. -1.40e+06. What is the difference between the Number of enrolments of both sexes in Cabo Verde in 2008 and the Number of enrolments of both sexes in Pakistan in 2009?
Your answer should be compact. -9.37e+06. What is the difference between the Number of enrolments of both sexes in Netherlands in 2008 and the Number of enrolments of both sexes in Pakistan in 2009?
Your response must be concise. -7.97e+06. What is the average Number of enrolments of both sexes in High income per year?
Your answer should be very brief. 1.08e+08. What is the average Number of enrolments of both sexes in Cabo Verde per year?
Your answer should be very brief. 5.06e+04. What is the average Number of enrolments of both sexes of Netherlands per year?
Ensure brevity in your answer.  1.43e+06. What is the average Number of enrolments of both sexes of Pakistan per year?
Provide a succinct answer. 7.38e+06. In the year 1990, what is the difference between the Number of enrolments of both sexes in High income and Number of enrolments of both sexes in Cabo Verde?
Your answer should be very brief. 1.04e+08. In the year 1990, what is the difference between the Number of enrolments of both sexes in High income and Number of enrolments of both sexes in Netherlands?
Provide a succinct answer. 1.03e+08. In the year 1990, what is the difference between the Number of enrolments of both sexes in High income and Number of enrolments of both sexes in Pakistan?
Ensure brevity in your answer.  1.00e+08. In the year 1990, what is the difference between the Number of enrolments of both sexes of Cabo Verde and Number of enrolments of both sexes of Netherlands?
Your response must be concise. -1.43e+06. In the year 1990, what is the difference between the Number of enrolments of both sexes of Cabo Verde and Number of enrolments of both sexes of Pakistan?
Ensure brevity in your answer.  -3.66e+06. In the year 1990, what is the difference between the Number of enrolments of both sexes in Netherlands and Number of enrolments of both sexes in Pakistan?
Provide a succinct answer. -2.23e+06. In the year 2003, what is the difference between the Number of enrolments of both sexes of High income and Number of enrolments of both sexes of Cabo Verde?
Give a very brief answer. 1.12e+08. In the year 2003, what is the difference between the Number of enrolments of both sexes in High income and Number of enrolments of both sexes in Netherlands?
Your response must be concise. 1.10e+08. In the year 2003, what is the difference between the Number of enrolments of both sexes of High income and Number of enrolments of both sexes of Pakistan?
Ensure brevity in your answer.  1.06e+08. In the year 2003, what is the difference between the Number of enrolments of both sexes of Cabo Verde and Number of enrolments of both sexes of Netherlands?
Provide a succinct answer. -1.37e+06. In the year 2003, what is the difference between the Number of enrolments of both sexes of Cabo Verde and Number of enrolments of both sexes of Pakistan?
Your answer should be compact. -5.68e+06. In the year 2003, what is the difference between the Number of enrolments of both sexes of Netherlands and Number of enrolments of both sexes of Pakistan?
Your answer should be compact. -4.32e+06. In the year 2004, what is the difference between the Number of enrolments of both sexes of High income and Number of enrolments of both sexes of Cabo Verde?
Your answer should be very brief. 1.10e+08. In the year 2004, what is the difference between the Number of enrolments of both sexes of High income and Number of enrolments of both sexes of Netherlands?
Make the answer very short. 1.09e+08. In the year 2004, what is the difference between the Number of enrolments of both sexes of High income and Number of enrolments of both sexes of Pakistan?
Keep it short and to the point. 1.04e+08. In the year 2004, what is the difference between the Number of enrolments of both sexes of Cabo Verde and Number of enrolments of both sexes of Netherlands?
Offer a terse response. -1.35e+06. In the year 2004, what is the difference between the Number of enrolments of both sexes in Cabo Verde and Number of enrolments of both sexes in Pakistan?
Your answer should be compact. -6.40e+06. In the year 2004, what is the difference between the Number of enrolments of both sexes of Netherlands and Number of enrolments of both sexes of Pakistan?
Provide a succinct answer. -5.05e+06. In the year 2005, what is the difference between the Number of enrolments of both sexes in High income and Number of enrolments of both sexes in Cabo Verde?
Provide a short and direct response. 1.10e+08. In the year 2005, what is the difference between the Number of enrolments of both sexes of High income and Number of enrolments of both sexes of Netherlands?
Ensure brevity in your answer.  1.08e+08. In the year 2005, what is the difference between the Number of enrolments of both sexes of High income and Number of enrolments of both sexes of Pakistan?
Your answer should be compact. 1.03e+08. In the year 2005, what is the difference between the Number of enrolments of both sexes in Cabo Verde and Number of enrolments of both sexes in Netherlands?
Your answer should be very brief. -1.36e+06. In the year 2005, what is the difference between the Number of enrolments of both sexes of Cabo Verde and Number of enrolments of both sexes of Pakistan?
Give a very brief answer. -6.80e+06. In the year 2005, what is the difference between the Number of enrolments of both sexes of Netherlands and Number of enrolments of both sexes of Pakistan?
Your answer should be very brief. -5.44e+06. In the year 2006, what is the difference between the Number of enrolments of both sexes in High income and Number of enrolments of both sexes in Cabo Verde?
Ensure brevity in your answer.  1.08e+08. In the year 2006, what is the difference between the Number of enrolments of both sexes in High income and Number of enrolments of both sexes in Netherlands?
Offer a terse response. 1.07e+08. In the year 2006, what is the difference between the Number of enrolments of both sexes of High income and Number of enrolments of both sexes of Pakistan?
Offer a terse response. 9.96e+07. In the year 2006, what is the difference between the Number of enrolments of both sexes in Cabo Verde and Number of enrolments of both sexes in Netherlands?
Your response must be concise. -1.36e+06. In the year 2006, what is the difference between the Number of enrolments of both sexes in Cabo Verde and Number of enrolments of both sexes in Pakistan?
Your response must be concise. -8.36e+06. In the year 2006, what is the difference between the Number of enrolments of both sexes of Netherlands and Number of enrolments of both sexes of Pakistan?
Keep it short and to the point. -7.00e+06. In the year 2007, what is the difference between the Number of enrolments of both sexes of High income and Number of enrolments of both sexes of Cabo Verde?
Provide a short and direct response. 1.07e+08. In the year 2007, what is the difference between the Number of enrolments of both sexes in High income and Number of enrolments of both sexes in Netherlands?
Provide a short and direct response. 1.06e+08. In the year 2007, what is the difference between the Number of enrolments of both sexes in High income and Number of enrolments of both sexes in Pakistan?
Provide a succinct answer. 9.79e+07. In the year 2007, what is the difference between the Number of enrolments of both sexes of Cabo Verde and Number of enrolments of both sexes of Netherlands?
Your response must be concise. -1.38e+06. In the year 2007, what is the difference between the Number of enrolments of both sexes of Cabo Verde and Number of enrolments of both sexes of Pakistan?
Provide a short and direct response. -9.08e+06. In the year 2007, what is the difference between the Number of enrolments of both sexes of Netherlands and Number of enrolments of both sexes of Pakistan?
Your response must be concise. -7.70e+06. In the year 2008, what is the difference between the Number of enrolments of both sexes of High income and Number of enrolments of both sexes of Cabo Verde?
Your answer should be compact. 1.06e+08. In the year 2008, what is the difference between the Number of enrolments of both sexes in High income and Number of enrolments of both sexes in Netherlands?
Make the answer very short. 1.05e+08. In the year 2008, what is the difference between the Number of enrolments of both sexes in High income and Number of enrolments of both sexes in Pakistan?
Give a very brief answer. 9.71e+07. In the year 2008, what is the difference between the Number of enrolments of both sexes in Cabo Verde and Number of enrolments of both sexes in Netherlands?
Make the answer very short. -1.40e+06. In the year 2008, what is the difference between the Number of enrolments of both sexes of Cabo Verde and Number of enrolments of both sexes of Pakistan?
Make the answer very short. -9.28e+06. In the year 2008, what is the difference between the Number of enrolments of both sexes of Netherlands and Number of enrolments of both sexes of Pakistan?
Ensure brevity in your answer.  -7.88e+06. In the year 2009, what is the difference between the Number of enrolments of both sexes of High income and Number of enrolments of both sexes of Cabo Verde?
Provide a short and direct response. 1.05e+08. In the year 2009, what is the difference between the Number of enrolments of both sexes of High income and Number of enrolments of both sexes of Netherlands?
Provide a short and direct response. 1.04e+08. In the year 2009, what is the difference between the Number of enrolments of both sexes of High income and Number of enrolments of both sexes of Pakistan?
Ensure brevity in your answer.  9.61e+07. In the year 2009, what is the difference between the Number of enrolments of both sexes in Cabo Verde and Number of enrolments of both sexes in Netherlands?
Ensure brevity in your answer.  -1.40e+06. In the year 2009, what is the difference between the Number of enrolments of both sexes of Cabo Verde and Number of enrolments of both sexes of Pakistan?
Provide a succinct answer. -9.37e+06. In the year 2009, what is the difference between the Number of enrolments of both sexes of Netherlands and Number of enrolments of both sexes of Pakistan?
Your answer should be very brief. -7.97e+06. What is the ratio of the Number of enrolments of both sexes in High income in 1990 to that in 2003?
Ensure brevity in your answer.  0.93. What is the ratio of the Number of enrolments of both sexes of Cabo Verde in 1990 to that in 2003?
Offer a terse response. 0.16. What is the ratio of the Number of enrolments of both sexes of Netherlands in 1990 to that in 2003?
Offer a terse response. 1.02. What is the ratio of the Number of enrolments of both sexes of Pakistan in 1990 to that in 2003?
Keep it short and to the point. 0.64. What is the ratio of the Number of enrolments of both sexes of High income in 1990 to that in 2004?
Give a very brief answer. 0.94. What is the ratio of the Number of enrolments of both sexes of Cabo Verde in 1990 to that in 2004?
Offer a terse response. 0.16. What is the ratio of the Number of enrolments of both sexes in Netherlands in 1990 to that in 2004?
Keep it short and to the point. 1.03. What is the ratio of the Number of enrolments of both sexes in Pakistan in 1990 to that in 2004?
Ensure brevity in your answer.  0.57. What is the ratio of the Number of enrolments of both sexes in High income in 1990 to that in 2005?
Provide a short and direct response. 0.95. What is the ratio of the Number of enrolments of both sexes in Cabo Verde in 1990 to that in 2005?
Give a very brief answer. 0.15. What is the ratio of the Number of enrolments of both sexes in Netherlands in 1990 to that in 2005?
Your response must be concise. 1.02. What is the ratio of the Number of enrolments of both sexes of Pakistan in 1990 to that in 2005?
Your response must be concise. 0.53. What is the ratio of the Number of enrolments of both sexes in High income in 1990 to that in 2006?
Keep it short and to the point. 0.96. What is the ratio of the Number of enrolments of both sexes of Cabo Verde in 1990 to that in 2006?
Your response must be concise. 0.13. What is the ratio of the Number of enrolments of both sexes in Netherlands in 1990 to that in 2006?
Your answer should be very brief. 1.01. What is the ratio of the Number of enrolments of both sexes of Pakistan in 1990 to that in 2006?
Make the answer very short. 0.44. What is the ratio of the Number of enrolments of both sexes of High income in 1990 to that in 2007?
Your response must be concise. 0.97. What is the ratio of the Number of enrolments of both sexes in Cabo Verde in 1990 to that in 2007?
Provide a short and direct response. 0.13. What is the ratio of the Number of enrolments of both sexes of Netherlands in 1990 to that in 2007?
Offer a very short reply. 0.99. What is the ratio of the Number of enrolments of both sexes of Pakistan in 1990 to that in 2007?
Your answer should be compact. 0.4. What is the ratio of the Number of enrolments of both sexes of High income in 1990 to that in 2008?
Offer a terse response. 0.98. What is the ratio of the Number of enrolments of both sexes of Cabo Verde in 1990 to that in 2008?
Provide a succinct answer. 0.13. What is the ratio of the Number of enrolments of both sexes of Netherlands in 1990 to that in 2008?
Give a very brief answer. 0.98. What is the ratio of the Number of enrolments of both sexes of Pakistan in 1990 to that in 2008?
Give a very brief answer. 0.39. What is the ratio of the Number of enrolments of both sexes in High income in 1990 to that in 2009?
Provide a succinct answer. 0.99. What is the ratio of the Number of enrolments of both sexes of Cabo Verde in 1990 to that in 2009?
Your answer should be compact. 0.13. What is the ratio of the Number of enrolments of both sexes of Netherlands in 1990 to that in 2009?
Provide a succinct answer. 0.98. What is the ratio of the Number of enrolments of both sexes of Pakistan in 1990 to that in 2009?
Give a very brief answer. 0.39. What is the ratio of the Number of enrolments of both sexes in High income in 2003 to that in 2004?
Your answer should be very brief. 1.02. What is the ratio of the Number of enrolments of both sexes in Netherlands in 2003 to that in 2004?
Make the answer very short. 1.01. What is the ratio of the Number of enrolments of both sexes in Pakistan in 2003 to that in 2004?
Give a very brief answer. 0.89. What is the ratio of the Number of enrolments of both sexes of High income in 2003 to that in 2005?
Ensure brevity in your answer.  1.02. What is the ratio of the Number of enrolments of both sexes in Cabo Verde in 2003 to that in 2005?
Ensure brevity in your answer.  0.94. What is the ratio of the Number of enrolments of both sexes in Pakistan in 2003 to that in 2005?
Offer a very short reply. 0.84. What is the ratio of the Number of enrolments of both sexes in High income in 2003 to that in 2006?
Your response must be concise. 1.04. What is the ratio of the Number of enrolments of both sexes in Cabo Verde in 2003 to that in 2006?
Provide a succinct answer. 0.81. What is the ratio of the Number of enrolments of both sexes in Netherlands in 2003 to that in 2006?
Provide a succinct answer. 0.99. What is the ratio of the Number of enrolments of both sexes of Pakistan in 2003 to that in 2006?
Offer a very short reply. 0.68. What is the ratio of the Number of enrolments of both sexes of High income in 2003 to that in 2007?
Offer a very short reply. 1.04. What is the ratio of the Number of enrolments of both sexes in Cabo Verde in 2003 to that in 2007?
Your answer should be compact. 0.81. What is the ratio of the Number of enrolments of both sexes of Pakistan in 2003 to that in 2007?
Provide a succinct answer. 0.63. What is the ratio of the Number of enrolments of both sexes in High income in 2003 to that in 2008?
Your answer should be very brief. 1.05. What is the ratio of the Number of enrolments of both sexes of Pakistan in 2003 to that in 2008?
Give a very brief answer. 0.61. What is the ratio of the Number of enrolments of both sexes in High income in 2003 to that in 2009?
Give a very brief answer. 1.06. What is the ratio of the Number of enrolments of both sexes in Cabo Verde in 2003 to that in 2009?
Give a very brief answer. 0.81. What is the ratio of the Number of enrolments of both sexes in Pakistan in 2003 to that in 2009?
Keep it short and to the point. 0.61. What is the ratio of the Number of enrolments of both sexes of Cabo Verde in 2004 to that in 2005?
Keep it short and to the point. 0.95. What is the ratio of the Number of enrolments of both sexes of Netherlands in 2004 to that in 2005?
Make the answer very short. 0.99. What is the ratio of the Number of enrolments of both sexes of High income in 2004 to that in 2006?
Your response must be concise. 1.02. What is the ratio of the Number of enrolments of both sexes in Cabo Verde in 2004 to that in 2006?
Offer a very short reply. 0.81. What is the ratio of the Number of enrolments of both sexes of Netherlands in 2004 to that in 2006?
Your answer should be very brief. 0.98. What is the ratio of the Number of enrolments of both sexes of Pakistan in 2004 to that in 2006?
Offer a very short reply. 0.77. What is the ratio of the Number of enrolments of both sexes in High income in 2004 to that in 2007?
Provide a succinct answer. 1.03. What is the ratio of the Number of enrolments of both sexes in Cabo Verde in 2004 to that in 2007?
Provide a succinct answer. 0.82. What is the ratio of the Number of enrolments of both sexes in Netherlands in 2004 to that in 2007?
Give a very brief answer. 0.97. What is the ratio of the Number of enrolments of both sexes of Pakistan in 2004 to that in 2007?
Your response must be concise. 0.71. What is the ratio of the Number of enrolments of both sexes of High income in 2004 to that in 2008?
Offer a very short reply. 1.03. What is the ratio of the Number of enrolments of both sexes of Cabo Verde in 2004 to that in 2008?
Offer a terse response. 0.8. What is the ratio of the Number of enrolments of both sexes of Netherlands in 2004 to that in 2008?
Provide a succinct answer. 0.96. What is the ratio of the Number of enrolments of both sexes in Pakistan in 2004 to that in 2008?
Give a very brief answer. 0.69. What is the ratio of the Number of enrolments of both sexes in High income in 2004 to that in 2009?
Offer a terse response. 1.04. What is the ratio of the Number of enrolments of both sexes of Cabo Verde in 2004 to that in 2009?
Make the answer very short. 0.82. What is the ratio of the Number of enrolments of both sexes of Netherlands in 2004 to that in 2009?
Your response must be concise. 0.95. What is the ratio of the Number of enrolments of both sexes of Pakistan in 2004 to that in 2009?
Make the answer very short. 0.68. What is the ratio of the Number of enrolments of both sexes of High income in 2005 to that in 2006?
Offer a terse response. 1.01. What is the ratio of the Number of enrolments of both sexes in Cabo Verde in 2005 to that in 2006?
Provide a succinct answer. 0.86. What is the ratio of the Number of enrolments of both sexes of Pakistan in 2005 to that in 2006?
Your answer should be very brief. 0.81. What is the ratio of the Number of enrolments of both sexes in High income in 2005 to that in 2007?
Ensure brevity in your answer.  1.02. What is the ratio of the Number of enrolments of both sexes of Cabo Verde in 2005 to that in 2007?
Your answer should be compact. 0.87. What is the ratio of the Number of enrolments of both sexes of Netherlands in 2005 to that in 2007?
Offer a very short reply. 0.98. What is the ratio of the Number of enrolments of both sexes of Pakistan in 2005 to that in 2007?
Provide a short and direct response. 0.75. What is the ratio of the Number of enrolments of both sexes in High income in 2005 to that in 2008?
Offer a very short reply. 1.03. What is the ratio of the Number of enrolments of both sexes in Cabo Verde in 2005 to that in 2008?
Give a very brief answer. 0.85. What is the ratio of the Number of enrolments of both sexes in Netherlands in 2005 to that in 2008?
Offer a very short reply. 0.97. What is the ratio of the Number of enrolments of both sexes in Pakistan in 2005 to that in 2008?
Give a very brief answer. 0.73. What is the ratio of the Number of enrolments of both sexes in High income in 2005 to that in 2009?
Your answer should be very brief. 1.04. What is the ratio of the Number of enrolments of both sexes in Cabo Verde in 2005 to that in 2009?
Provide a short and direct response. 0.87. What is the ratio of the Number of enrolments of both sexes in Netherlands in 2005 to that in 2009?
Give a very brief answer. 0.96. What is the ratio of the Number of enrolments of both sexes in Pakistan in 2005 to that in 2009?
Your answer should be compact. 0.73. What is the ratio of the Number of enrolments of both sexes of High income in 2006 to that in 2007?
Provide a succinct answer. 1.01. What is the ratio of the Number of enrolments of both sexes in Cabo Verde in 2006 to that in 2007?
Offer a very short reply. 1.01. What is the ratio of the Number of enrolments of both sexes in Netherlands in 2006 to that in 2007?
Your response must be concise. 0.99. What is the ratio of the Number of enrolments of both sexes of Pakistan in 2006 to that in 2007?
Provide a short and direct response. 0.92. What is the ratio of the Number of enrolments of both sexes in High income in 2006 to that in 2008?
Your answer should be compact. 1.01. What is the ratio of the Number of enrolments of both sexes in Netherlands in 2006 to that in 2008?
Offer a very short reply. 0.97. What is the ratio of the Number of enrolments of both sexes in Pakistan in 2006 to that in 2008?
Provide a succinct answer. 0.9. What is the ratio of the Number of enrolments of both sexes of High income in 2006 to that in 2009?
Offer a terse response. 1.02. What is the ratio of the Number of enrolments of both sexes in Cabo Verde in 2006 to that in 2009?
Provide a short and direct response. 1.01. What is the ratio of the Number of enrolments of both sexes in Netherlands in 2006 to that in 2009?
Offer a terse response. 0.97. What is the ratio of the Number of enrolments of both sexes of Pakistan in 2006 to that in 2009?
Offer a terse response. 0.89. What is the ratio of the Number of enrolments of both sexes in Cabo Verde in 2007 to that in 2008?
Provide a short and direct response. 0.98. What is the ratio of the Number of enrolments of both sexes in Netherlands in 2007 to that in 2008?
Ensure brevity in your answer.  0.99. What is the ratio of the Number of enrolments of both sexes in Pakistan in 2007 to that in 2008?
Your answer should be compact. 0.98. What is the ratio of the Number of enrolments of both sexes in Netherlands in 2007 to that in 2009?
Ensure brevity in your answer.  0.99. What is the ratio of the Number of enrolments of both sexes of Pakistan in 2007 to that in 2009?
Make the answer very short. 0.97. What is the ratio of the Number of enrolments of both sexes of High income in 2008 to that in 2009?
Your response must be concise. 1.01. What is the ratio of the Number of enrolments of both sexes of Cabo Verde in 2008 to that in 2009?
Your answer should be very brief. 1.02. What is the ratio of the Number of enrolments of both sexes of Netherlands in 2008 to that in 2009?
Make the answer very short. 1. What is the ratio of the Number of enrolments of both sexes of Pakistan in 2008 to that in 2009?
Your answer should be compact. 0.99. What is the difference between the highest and the second highest Number of enrolments of both sexes in High income?
Provide a succinct answer. 1.83e+06. What is the difference between the highest and the second highest Number of enrolments of both sexes of Cabo Verde?
Provide a succinct answer. 441. What is the difference between the highest and the second highest Number of enrolments of both sexes in Netherlands?
Make the answer very short. 1958. What is the difference between the highest and the second highest Number of enrolments of both sexes in Pakistan?
Give a very brief answer. 9.30e+04. What is the difference between the highest and the lowest Number of enrolments of both sexes in High income?
Your response must be concise. 7.92e+06. What is the difference between the highest and the lowest Number of enrolments of both sexes of Cabo Verde?
Your response must be concise. 5.40e+04. What is the difference between the highest and the lowest Number of enrolments of both sexes of Netherlands?
Offer a terse response. 6.58e+04. What is the difference between the highest and the lowest Number of enrolments of both sexes of Pakistan?
Your answer should be very brief. 5.77e+06. 